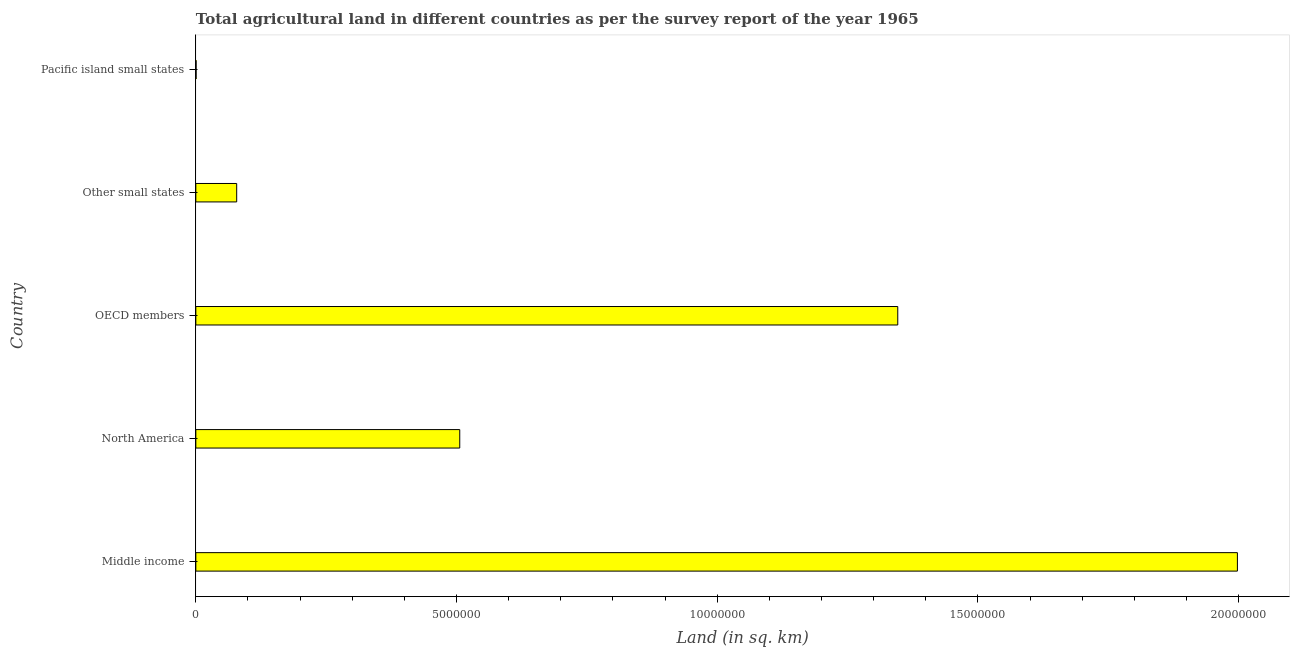Does the graph contain grids?
Your answer should be compact. No. What is the title of the graph?
Offer a terse response. Total agricultural land in different countries as per the survey report of the year 1965. What is the label or title of the X-axis?
Your response must be concise. Land (in sq. km). What is the agricultural land in Other small states?
Offer a very short reply. 7.84e+05. Across all countries, what is the maximum agricultural land?
Provide a short and direct response. 2.00e+07. Across all countries, what is the minimum agricultural land?
Give a very brief answer. 5280. In which country was the agricultural land maximum?
Keep it short and to the point. Middle income. In which country was the agricultural land minimum?
Offer a terse response. Pacific island small states. What is the sum of the agricultural land?
Keep it short and to the point. 3.93e+07. What is the difference between the agricultural land in Middle income and OECD members?
Ensure brevity in your answer.  6.51e+06. What is the average agricultural land per country?
Offer a very short reply. 7.86e+06. What is the median agricultural land?
Your answer should be compact. 5.06e+06. What is the ratio of the agricultural land in Middle income to that in North America?
Give a very brief answer. 3.95. What is the difference between the highest and the second highest agricultural land?
Offer a very short reply. 6.51e+06. What is the difference between the highest and the lowest agricultural land?
Keep it short and to the point. 2.00e+07. Are all the bars in the graph horizontal?
Your answer should be very brief. Yes. Are the values on the major ticks of X-axis written in scientific E-notation?
Offer a very short reply. No. What is the Land (in sq. km) of Middle income?
Offer a very short reply. 2.00e+07. What is the Land (in sq. km) of North America?
Provide a succinct answer. 5.06e+06. What is the Land (in sq. km) of OECD members?
Provide a succinct answer. 1.35e+07. What is the Land (in sq. km) in Other small states?
Make the answer very short. 7.84e+05. What is the Land (in sq. km) of Pacific island small states?
Your response must be concise. 5280. What is the difference between the Land (in sq. km) in Middle income and North America?
Ensure brevity in your answer.  1.49e+07. What is the difference between the Land (in sq. km) in Middle income and OECD members?
Give a very brief answer. 6.51e+06. What is the difference between the Land (in sq. km) in Middle income and Other small states?
Offer a terse response. 1.92e+07. What is the difference between the Land (in sq. km) in Middle income and Pacific island small states?
Ensure brevity in your answer.  2.00e+07. What is the difference between the Land (in sq. km) in North America and OECD members?
Provide a succinct answer. -8.40e+06. What is the difference between the Land (in sq. km) in North America and Other small states?
Provide a short and direct response. 4.28e+06. What is the difference between the Land (in sq. km) in North America and Pacific island small states?
Your response must be concise. 5.06e+06. What is the difference between the Land (in sq. km) in OECD members and Other small states?
Provide a succinct answer. 1.27e+07. What is the difference between the Land (in sq. km) in OECD members and Pacific island small states?
Give a very brief answer. 1.35e+07. What is the difference between the Land (in sq. km) in Other small states and Pacific island small states?
Offer a terse response. 7.79e+05. What is the ratio of the Land (in sq. km) in Middle income to that in North America?
Offer a very short reply. 3.95. What is the ratio of the Land (in sq. km) in Middle income to that in OECD members?
Give a very brief answer. 1.48. What is the ratio of the Land (in sq. km) in Middle income to that in Other small states?
Provide a short and direct response. 25.49. What is the ratio of the Land (in sq. km) in Middle income to that in Pacific island small states?
Offer a terse response. 3783.76. What is the ratio of the Land (in sq. km) in North America to that in OECD members?
Make the answer very short. 0.38. What is the ratio of the Land (in sq. km) in North America to that in Other small states?
Make the answer very short. 6.46. What is the ratio of the Land (in sq. km) in North America to that in Pacific island small states?
Provide a succinct answer. 958.73. What is the ratio of the Land (in sq. km) in OECD members to that in Other small states?
Provide a short and direct response. 17.18. What is the ratio of the Land (in sq. km) in OECD members to that in Pacific island small states?
Your answer should be very brief. 2549.93. What is the ratio of the Land (in sq. km) in Other small states to that in Pacific island small states?
Provide a short and direct response. 148.44. 